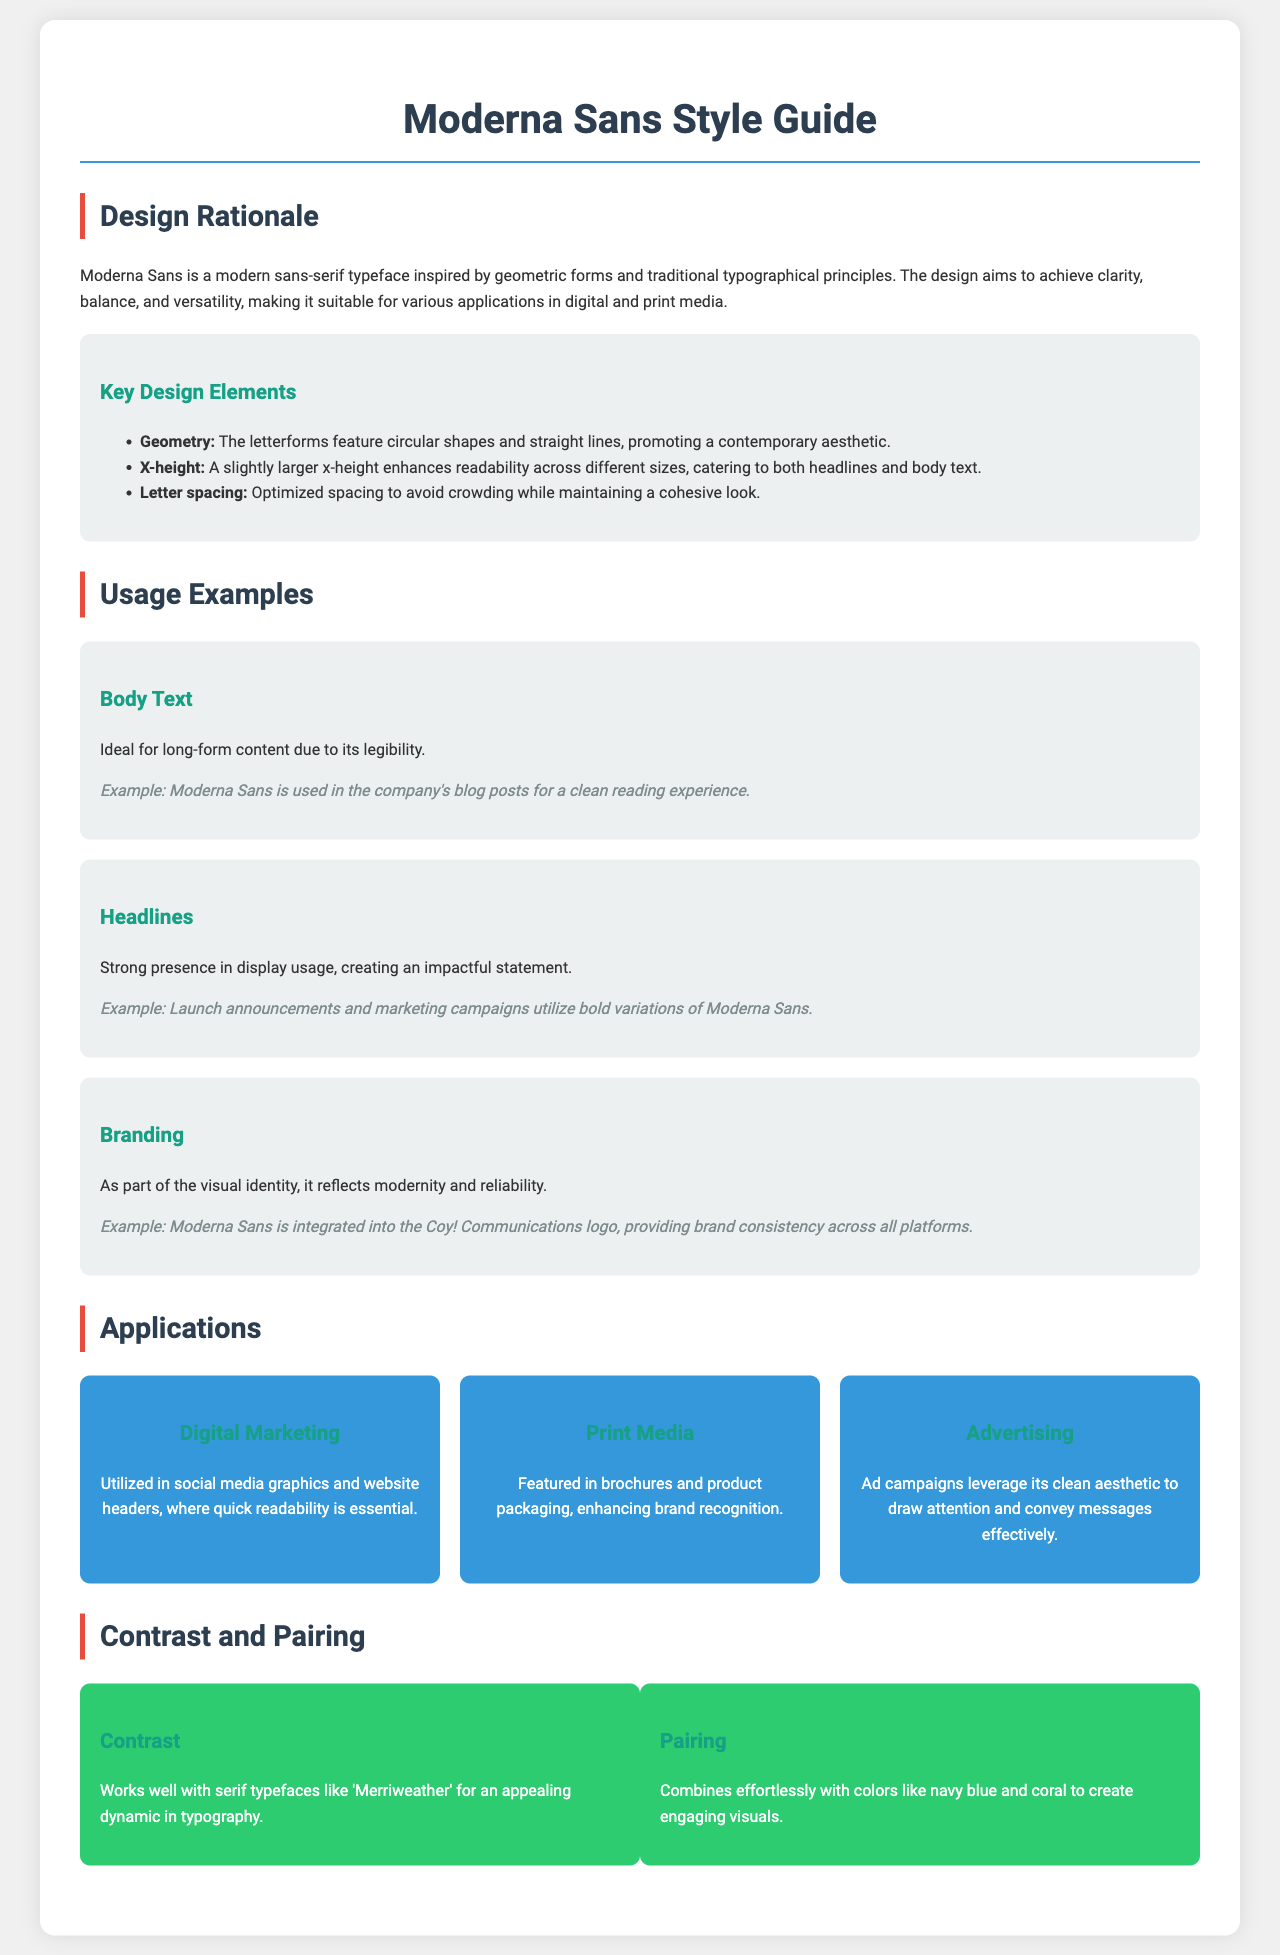What is the name of the typeface? The document states that the typeface is called "Moderna Sans."
Answer: Moderna Sans What is the primary design inspiration for Moderna Sans? The design is inspired by "geometric forms and traditional typographical principles."
Answer: geometric forms What feature enhances the readability of Moderna Sans? A slightly larger x-height is mentioned as enhancing readability across different sizes.
Answer: larger x-height In what context is Moderna Sans used for body text? It is ideal for "long-form content due to its legibility."
Answer: long-form content What type of applications is Moderna Sans utilized in for digital marketing? The document mentions it is used in "social media graphics and website headers."
Answer: social media graphics Which color combinations work well with Moderna Sans? It combines effortlessly with "navy blue and coral."
Answer: navy blue and coral What does Moderna Sans reflect in branding? It reflects "modernity and reliability" as part of the visual identity.
Answer: modernity and reliability In what type of media is Moderna Sans featured for print? It is featured in "brochures and product packaging."
Answer: brochures and product packaging What is one of the key design elements of Moderna Sans? One key design element is "optimized spacing to avoid crowding."
Answer: optimized spacing 